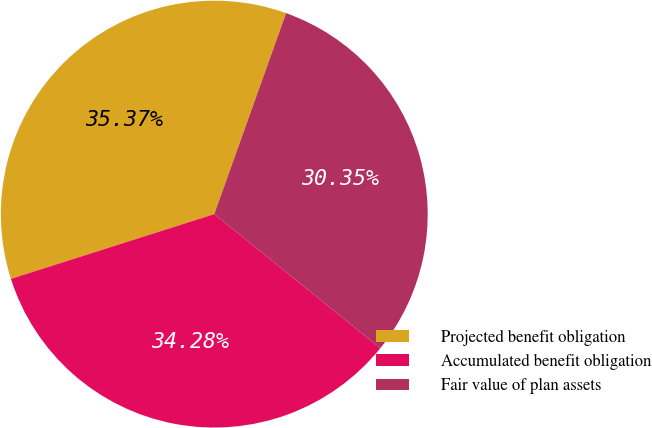Convert chart to OTSL. <chart><loc_0><loc_0><loc_500><loc_500><pie_chart><fcel>Projected benefit obligation<fcel>Accumulated benefit obligation<fcel>Fair value of plan assets<nl><fcel>35.37%<fcel>34.28%<fcel>30.35%<nl></chart> 